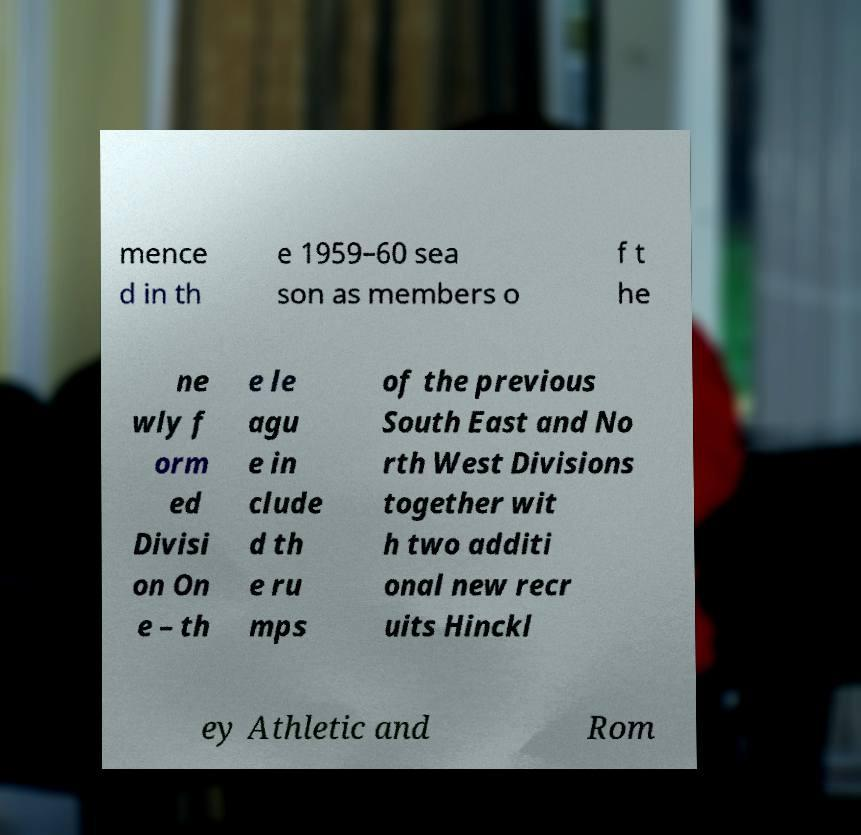Could you assist in decoding the text presented in this image and type it out clearly? mence d in th e 1959–60 sea son as members o f t he ne wly f orm ed Divisi on On e – th e le agu e in clude d th e ru mps of the previous South East and No rth West Divisions together wit h two additi onal new recr uits Hinckl ey Athletic and Rom 